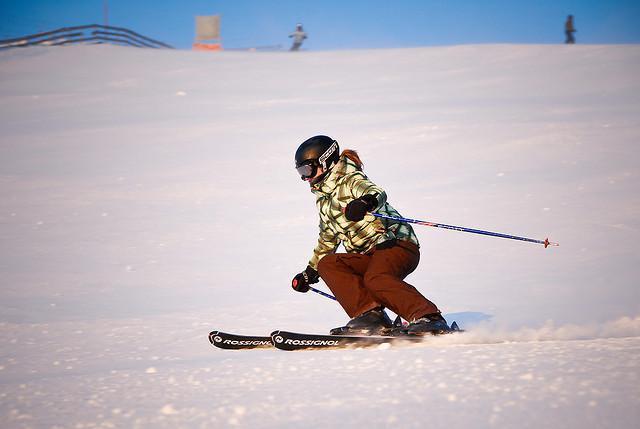How many people do you see?
Give a very brief answer. 3. 